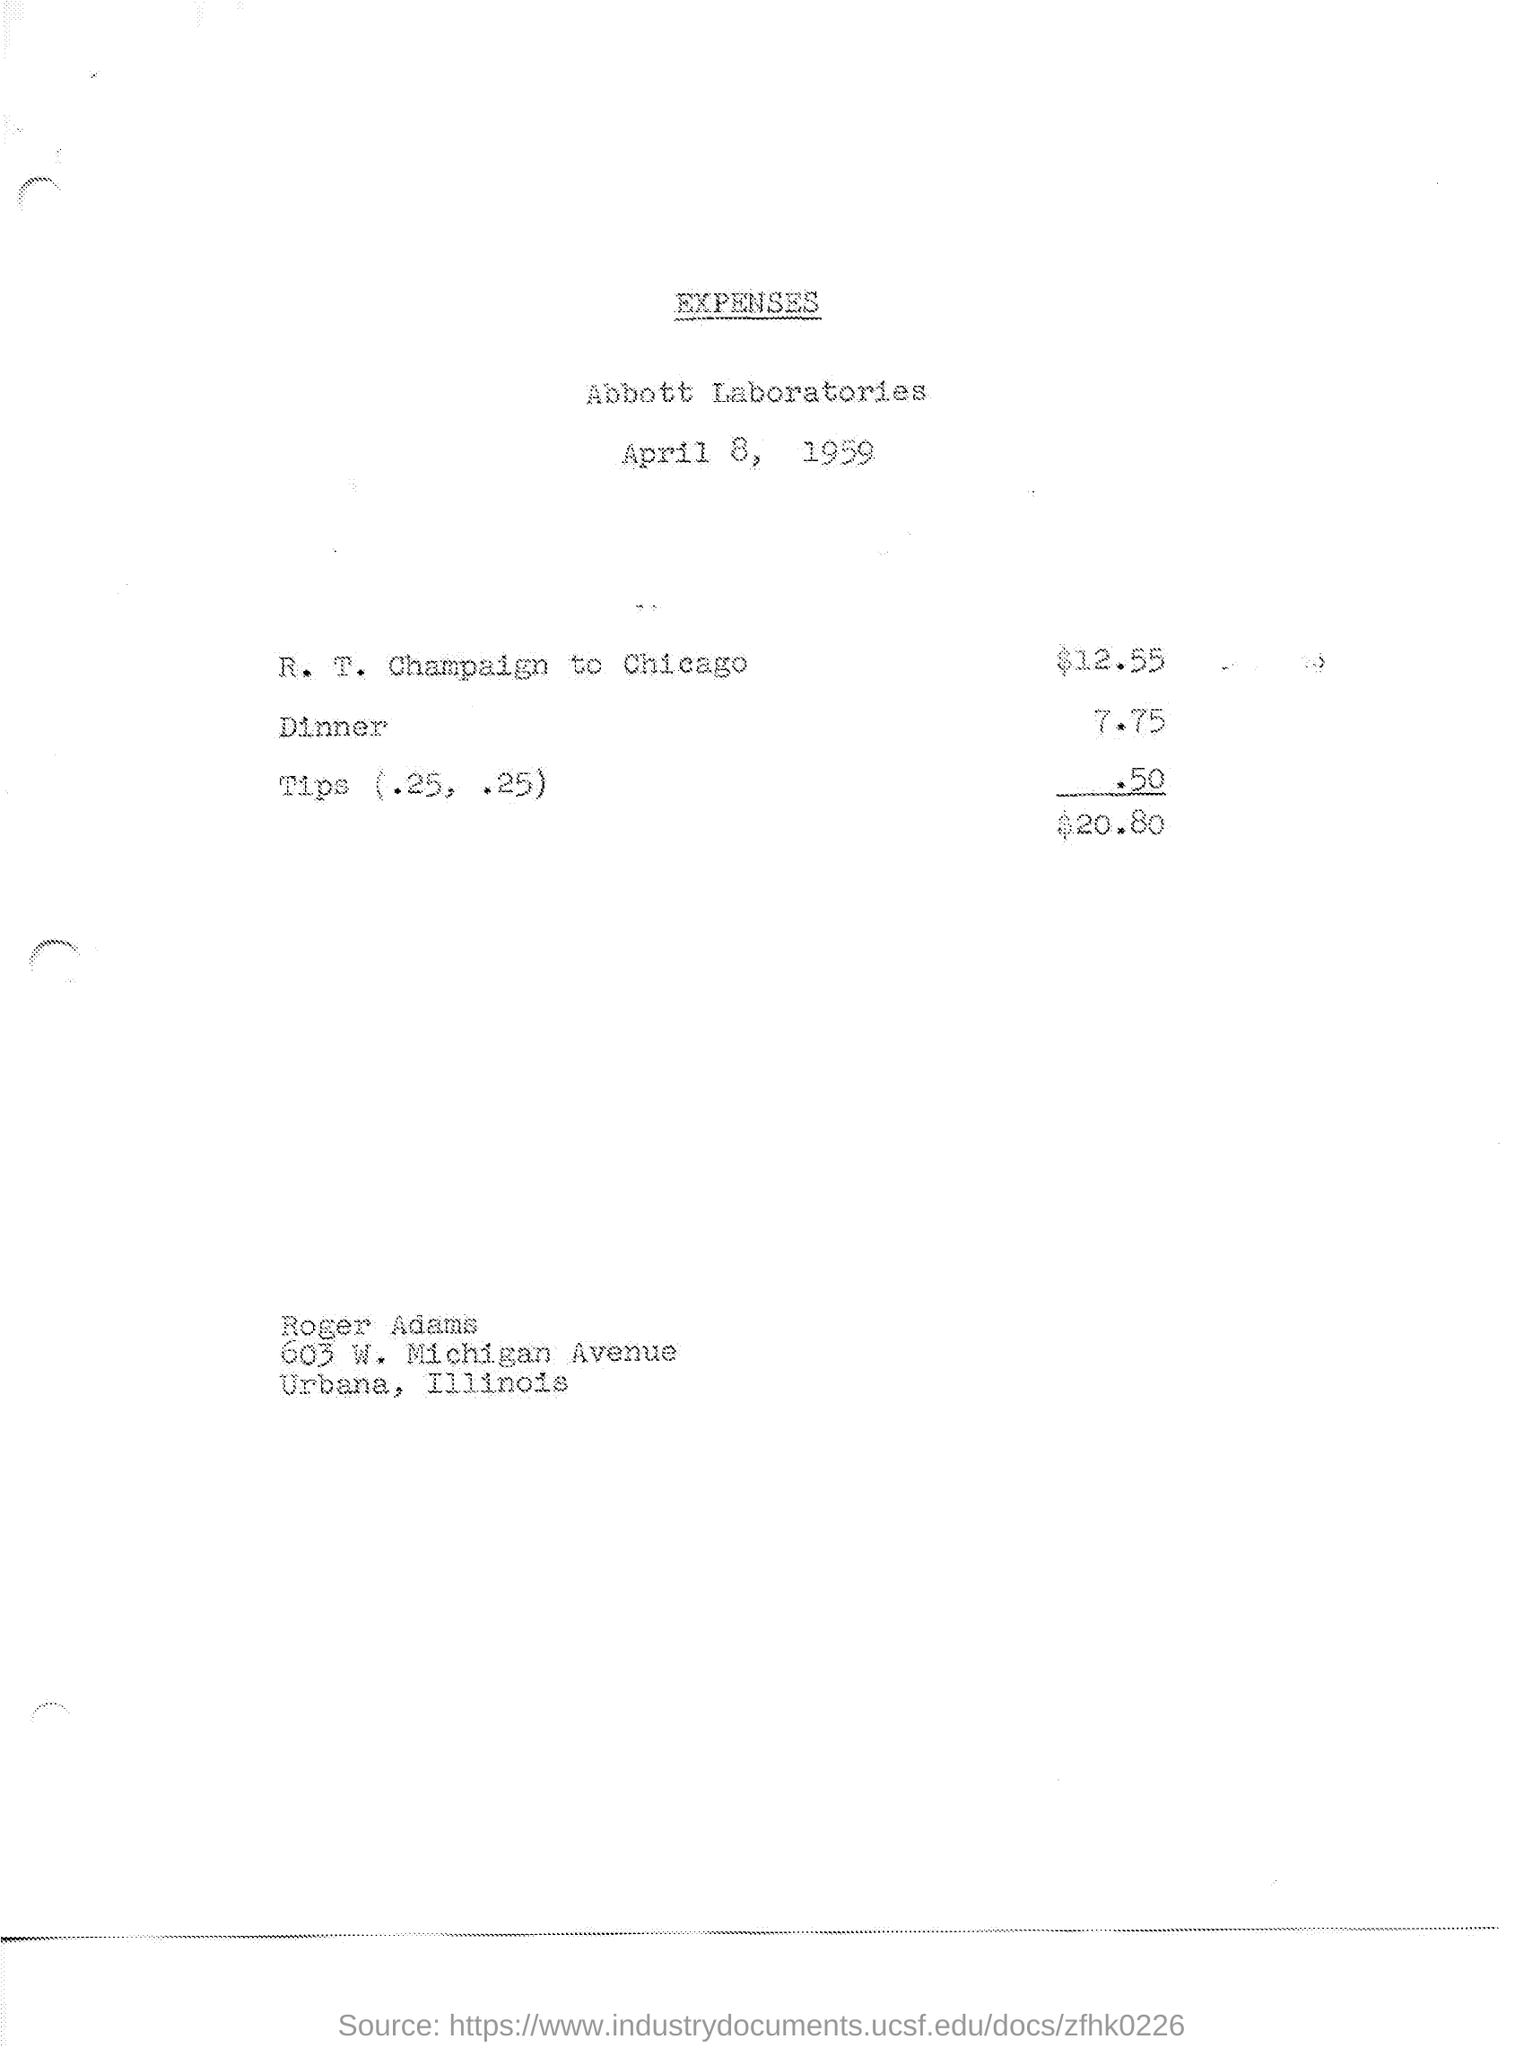What is the grand total of all the expenses listed? The grand total of all the expenses listed on the sheet is $20.80. 